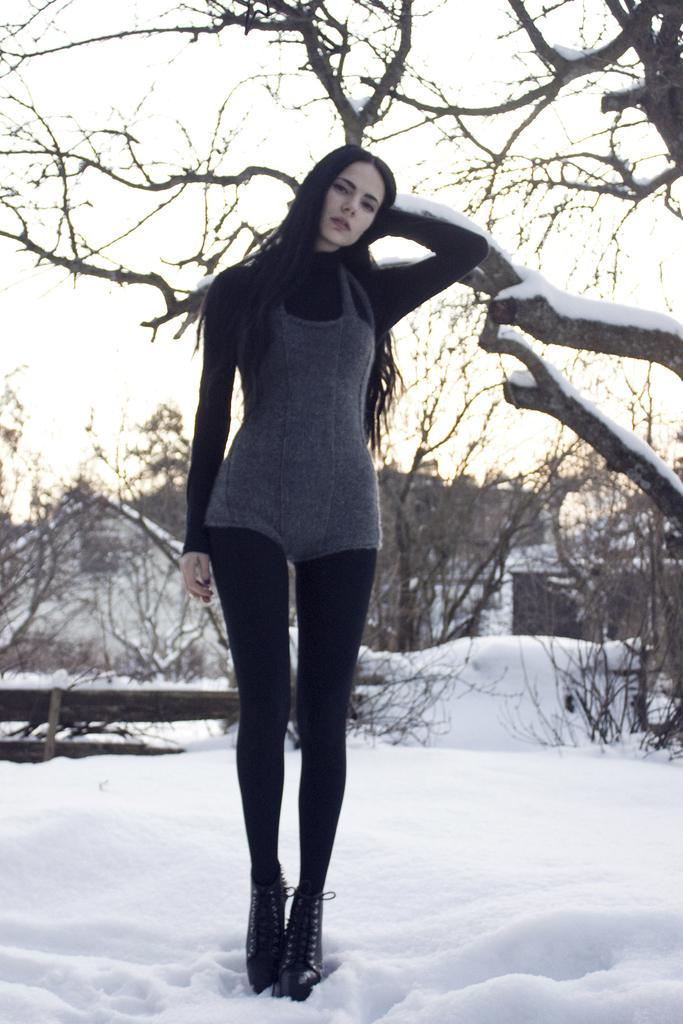What is the condition of the land in the image? The land is covered with snow. Can you describe the person in the image? There is a person standing in the image. What can be seen in the background of the image? There are houses and trees in the background of the image. What type of fang can be seen in the image? There is no fang present in the image. Can you tell me how many cellars are visible in the image? There is no mention of cellars in the image; it features a person standing on snow-covered land with houses and trees in the background. 